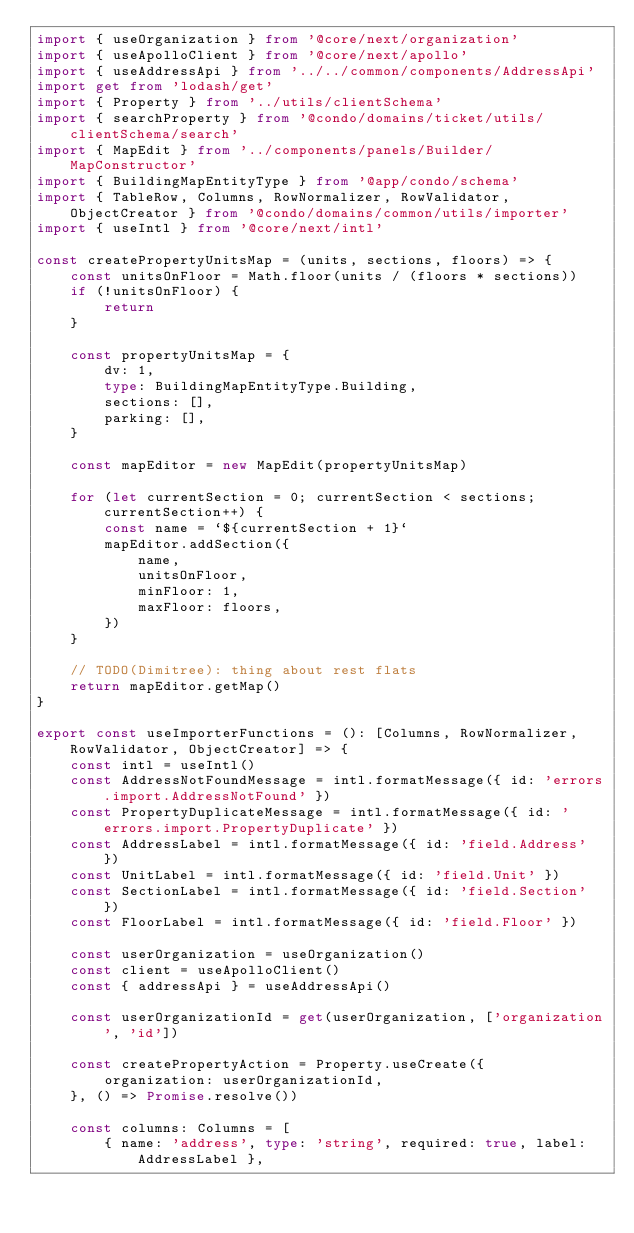<code> <loc_0><loc_0><loc_500><loc_500><_TypeScript_>import { useOrganization } from '@core/next/organization'
import { useApolloClient } from '@core/next/apollo'
import { useAddressApi } from '../../common/components/AddressApi'
import get from 'lodash/get'
import { Property } from '../utils/clientSchema'
import { searchProperty } from '@condo/domains/ticket/utils/clientSchema/search'
import { MapEdit } from '../components/panels/Builder/MapConstructor'
import { BuildingMapEntityType } from '@app/condo/schema'
import { TableRow, Columns, RowNormalizer, RowValidator, ObjectCreator } from '@condo/domains/common/utils/importer'
import { useIntl } from '@core/next/intl'

const createPropertyUnitsMap = (units, sections, floors) => {
    const unitsOnFloor = Math.floor(units / (floors * sections))
    if (!unitsOnFloor) {
        return
    }

    const propertyUnitsMap = {
        dv: 1,
        type: BuildingMapEntityType.Building,
        sections: [],
        parking: [],
    }

    const mapEditor = new MapEdit(propertyUnitsMap)

    for (let currentSection = 0; currentSection < sections; currentSection++) {
        const name = `${currentSection + 1}`
        mapEditor.addSection({
            name,
            unitsOnFloor,
            minFloor: 1,
            maxFloor: floors,
        })
    }

    // TODO(Dimitree): thing about rest flats
    return mapEditor.getMap()
}

export const useImporterFunctions = (): [Columns, RowNormalizer, RowValidator, ObjectCreator] => {
    const intl = useIntl()
    const AddressNotFoundMessage = intl.formatMessage({ id: 'errors.import.AddressNotFound' })
    const PropertyDuplicateMessage = intl.formatMessage({ id: 'errors.import.PropertyDuplicate' })
    const AddressLabel = intl.formatMessage({ id: 'field.Address' })
    const UnitLabel = intl.formatMessage({ id: 'field.Unit' })
    const SectionLabel = intl.formatMessage({ id: 'field.Section' })
    const FloorLabel = intl.formatMessage({ id: 'field.Floor' })

    const userOrganization = useOrganization()
    const client = useApolloClient()
    const { addressApi } = useAddressApi()

    const userOrganizationId = get(userOrganization, ['organization', 'id'])

    const createPropertyAction = Property.useCreate({
        organization: userOrganizationId,
    }, () => Promise.resolve())

    const columns: Columns = [
        { name: 'address', type: 'string', required: true, label: AddressLabel },</code> 